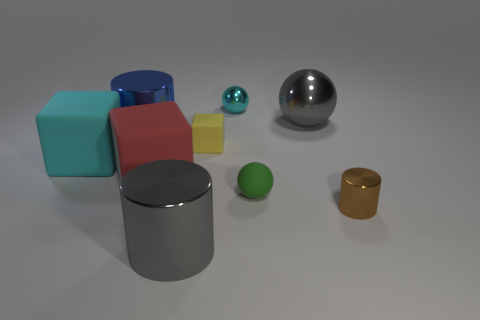What is the material of the large object that is the same color as the tiny metallic ball?
Offer a very short reply. Rubber. Are any tiny purple rubber objects visible?
Provide a succinct answer. No. Do the cyan rubber object and the tiny rubber thing that is behind the red block have the same shape?
Your response must be concise. Yes. There is a shiny sphere that is right of the metallic ball behind the gray metallic object that is on the right side of the yellow rubber block; what is its color?
Give a very brief answer. Gray. Are there any cyan blocks in front of the red thing?
Keep it short and to the point. No. Is there a gray sphere made of the same material as the tiny cylinder?
Offer a terse response. Yes. The big shiny ball is what color?
Keep it short and to the point. Gray. There is a object that is to the right of the big ball; is it the same shape as the yellow matte thing?
Make the answer very short. No. The big gray object on the left side of the small matte object that is in front of the big red cube that is in front of the tiny cyan sphere is what shape?
Your answer should be compact. Cylinder. What is the material of the small ball in front of the large cyan rubber block?
Offer a very short reply. Rubber. 